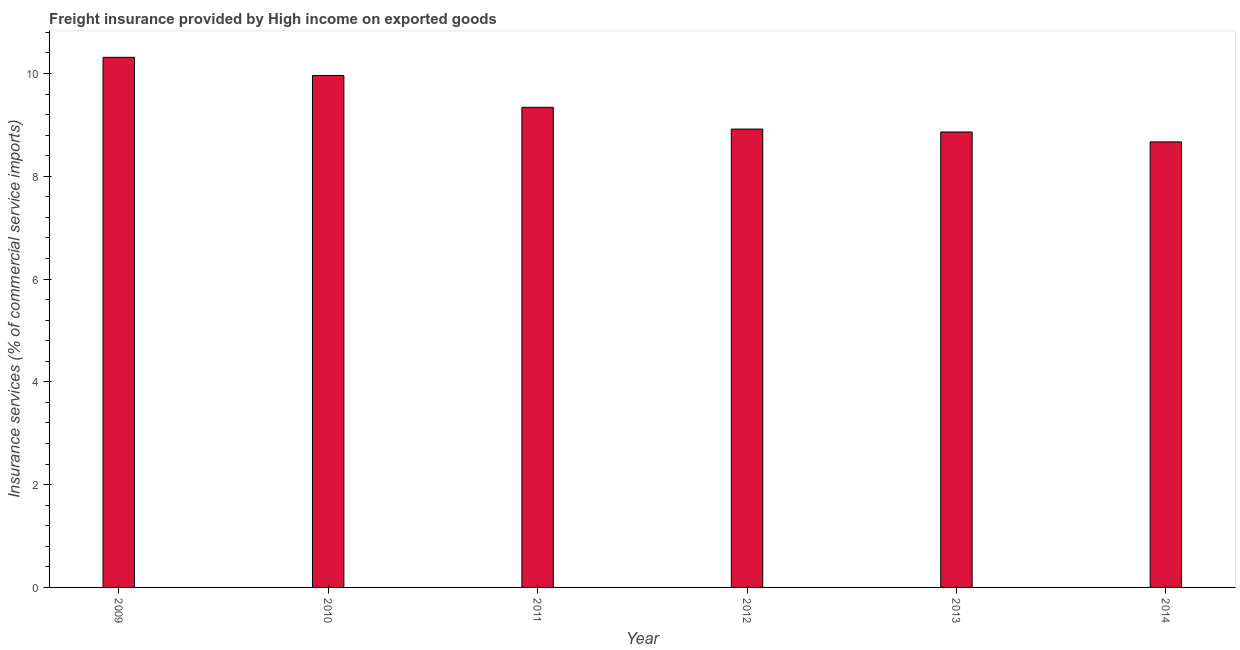Does the graph contain any zero values?
Provide a short and direct response. No. What is the title of the graph?
Offer a terse response. Freight insurance provided by High income on exported goods . What is the label or title of the X-axis?
Offer a very short reply. Year. What is the label or title of the Y-axis?
Your answer should be very brief. Insurance services (% of commercial service imports). What is the freight insurance in 2012?
Give a very brief answer. 8.92. Across all years, what is the maximum freight insurance?
Your answer should be compact. 10.31. Across all years, what is the minimum freight insurance?
Provide a succinct answer. 8.67. In which year was the freight insurance maximum?
Ensure brevity in your answer.  2009. In which year was the freight insurance minimum?
Your response must be concise. 2014. What is the sum of the freight insurance?
Offer a terse response. 56.06. What is the difference between the freight insurance in 2009 and 2013?
Your answer should be very brief. 1.45. What is the average freight insurance per year?
Give a very brief answer. 9.34. What is the median freight insurance?
Offer a very short reply. 9.13. In how many years, is the freight insurance greater than 8 %?
Provide a succinct answer. 6. Do a majority of the years between 2014 and 2009 (inclusive) have freight insurance greater than 4.8 %?
Make the answer very short. Yes. What is the ratio of the freight insurance in 2012 to that in 2014?
Offer a very short reply. 1.03. Is the freight insurance in 2009 less than that in 2012?
Provide a short and direct response. No. Is the difference between the freight insurance in 2010 and 2012 greater than the difference between any two years?
Give a very brief answer. No. What is the difference between the highest and the second highest freight insurance?
Offer a very short reply. 0.35. What is the difference between the highest and the lowest freight insurance?
Ensure brevity in your answer.  1.65. In how many years, is the freight insurance greater than the average freight insurance taken over all years?
Ensure brevity in your answer.  2. What is the difference between two consecutive major ticks on the Y-axis?
Your answer should be compact. 2. What is the Insurance services (% of commercial service imports) in 2009?
Provide a short and direct response. 10.31. What is the Insurance services (% of commercial service imports) in 2010?
Keep it short and to the point. 9.96. What is the Insurance services (% of commercial service imports) in 2011?
Offer a very short reply. 9.34. What is the Insurance services (% of commercial service imports) in 2012?
Keep it short and to the point. 8.92. What is the Insurance services (% of commercial service imports) in 2013?
Keep it short and to the point. 8.86. What is the Insurance services (% of commercial service imports) of 2014?
Ensure brevity in your answer.  8.67. What is the difference between the Insurance services (% of commercial service imports) in 2009 and 2010?
Provide a succinct answer. 0.35. What is the difference between the Insurance services (% of commercial service imports) in 2009 and 2011?
Make the answer very short. 0.97. What is the difference between the Insurance services (% of commercial service imports) in 2009 and 2012?
Offer a very short reply. 1.4. What is the difference between the Insurance services (% of commercial service imports) in 2009 and 2013?
Offer a very short reply. 1.45. What is the difference between the Insurance services (% of commercial service imports) in 2009 and 2014?
Offer a very short reply. 1.65. What is the difference between the Insurance services (% of commercial service imports) in 2010 and 2011?
Keep it short and to the point. 0.62. What is the difference between the Insurance services (% of commercial service imports) in 2010 and 2012?
Keep it short and to the point. 1.04. What is the difference between the Insurance services (% of commercial service imports) in 2010 and 2013?
Give a very brief answer. 1.1. What is the difference between the Insurance services (% of commercial service imports) in 2010 and 2014?
Offer a terse response. 1.29. What is the difference between the Insurance services (% of commercial service imports) in 2011 and 2012?
Your response must be concise. 0.42. What is the difference between the Insurance services (% of commercial service imports) in 2011 and 2013?
Give a very brief answer. 0.48. What is the difference between the Insurance services (% of commercial service imports) in 2011 and 2014?
Your answer should be compact. 0.67. What is the difference between the Insurance services (% of commercial service imports) in 2012 and 2013?
Keep it short and to the point. 0.06. What is the difference between the Insurance services (% of commercial service imports) in 2012 and 2014?
Offer a terse response. 0.25. What is the difference between the Insurance services (% of commercial service imports) in 2013 and 2014?
Offer a terse response. 0.19. What is the ratio of the Insurance services (% of commercial service imports) in 2009 to that in 2010?
Offer a very short reply. 1.04. What is the ratio of the Insurance services (% of commercial service imports) in 2009 to that in 2011?
Give a very brief answer. 1.1. What is the ratio of the Insurance services (% of commercial service imports) in 2009 to that in 2012?
Offer a very short reply. 1.16. What is the ratio of the Insurance services (% of commercial service imports) in 2009 to that in 2013?
Provide a short and direct response. 1.16. What is the ratio of the Insurance services (% of commercial service imports) in 2009 to that in 2014?
Provide a succinct answer. 1.19. What is the ratio of the Insurance services (% of commercial service imports) in 2010 to that in 2011?
Offer a very short reply. 1.07. What is the ratio of the Insurance services (% of commercial service imports) in 2010 to that in 2012?
Provide a succinct answer. 1.12. What is the ratio of the Insurance services (% of commercial service imports) in 2010 to that in 2013?
Ensure brevity in your answer.  1.12. What is the ratio of the Insurance services (% of commercial service imports) in 2010 to that in 2014?
Provide a succinct answer. 1.15. What is the ratio of the Insurance services (% of commercial service imports) in 2011 to that in 2012?
Keep it short and to the point. 1.05. What is the ratio of the Insurance services (% of commercial service imports) in 2011 to that in 2013?
Your answer should be compact. 1.05. What is the ratio of the Insurance services (% of commercial service imports) in 2011 to that in 2014?
Your answer should be very brief. 1.08. What is the ratio of the Insurance services (% of commercial service imports) in 2012 to that in 2014?
Your answer should be compact. 1.03. What is the ratio of the Insurance services (% of commercial service imports) in 2013 to that in 2014?
Provide a short and direct response. 1.02. 